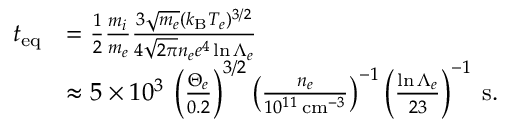<formula> <loc_0><loc_0><loc_500><loc_500>\begin{array} { r l } { t _ { e q } } & { = \frac { 1 } { 2 } \frac { m _ { i } } { m _ { e } } \frac { 3 \sqrt { m _ { e } } ( k _ { B } T _ { e } ) ^ { 3 / 2 } } { 4 \sqrt { 2 \pi } n _ { e } e ^ { 4 } \ln { \Lambda _ { e } } } } \\ & { \approx 5 \times 1 0 ^ { 3 } \, \left ( \frac { \Theta _ { e } } { 0 . 2 } \right ) ^ { 3 / 2 } \left ( \frac { n _ { e } } { 1 0 ^ { 1 1 } \, c m ^ { - 3 } } \right ) ^ { - 1 } \left ( \frac { \ln { \Lambda _ { e } } } { 2 3 } \right ) ^ { - 1 } \, s . } \end{array}</formula> 